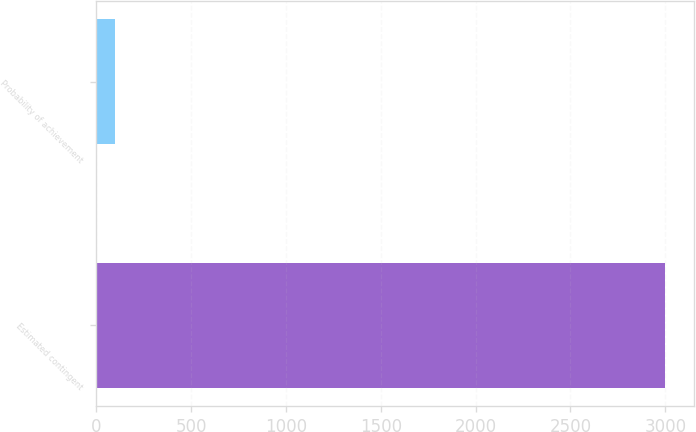Convert chart to OTSL. <chart><loc_0><loc_0><loc_500><loc_500><bar_chart><fcel>Estimated contingent<fcel>Probability of achievement<nl><fcel>3000<fcel>100<nl></chart> 